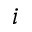<formula> <loc_0><loc_0><loc_500><loc_500>i</formula> 